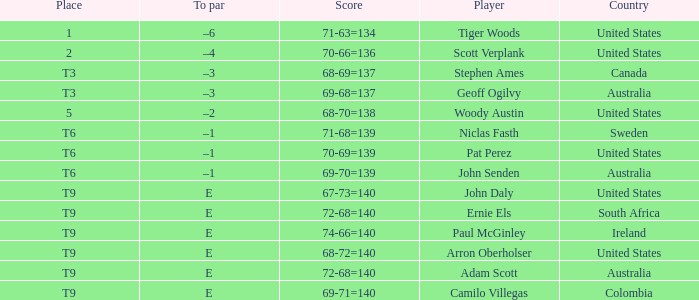What country is Adam Scott from? Australia. 